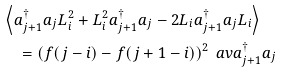Convert formula to latex. <formula><loc_0><loc_0><loc_500><loc_500>& \left \langle a _ { j + 1 } ^ { \dagger } a _ { j } L _ { i } ^ { 2 } + L _ { i } ^ { 2 } a _ { j + 1 } ^ { \dagger } a _ { j } - 2 L _ { i } a _ { j + 1 } ^ { \dagger } a _ { j } L _ { i } \right \rangle \\ & \quad = \left ( f ( j - i ) - f ( j + 1 - i ) \right ) ^ { 2 } \ a v { a _ { j + 1 } ^ { \dagger } a _ { j } }</formula> 